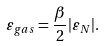Convert formula to latex. <formula><loc_0><loc_0><loc_500><loc_500>\varepsilon _ { g a s } = \frac { \beta } { 2 } | \varepsilon _ { N } | .</formula> 